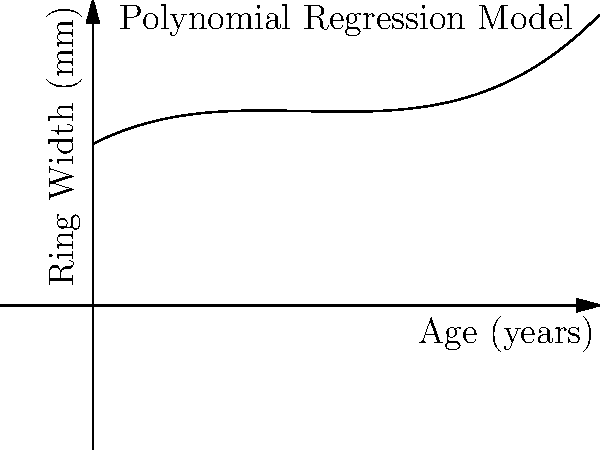As a retired carpenter with an interest in genealogy, you've come across an antique wooden chair that you believe belonged to your great-grandfather. Using your knowledge of tree rings and the polynomial regression model for estimating furniture age shown in the graph, what is the approximate age of the chair if the average ring width measured from a small, non-destructive sample is 65 mm? To estimate the age of the wooden chair using the polynomial regression model, we need to follow these steps:

1. The graph shows a polynomial function relating the age of wooden furniture to the width of tree rings.

2. The function appears to be a cubic polynomial of the form:
   $f(x) = ax^3 + bx^2 + cx + d$
   where $x$ is the age in years and $f(x)$ is the ring width in mm.

3. We need to find the $x$ value (age) that corresponds to $f(x) = 65$ mm (the measured ring width).

4. Looking at the graph, we can see that the 65 mm ring width intersects the curve at two points. Since we're dealing with an antique, we're interested in the larger age value.

5. By visual estimation, the intersection point we're interested in appears to be close to 15 years on the x-axis.

6. Given the imprecision of visual estimation and potential variations in actual measurements, it's reasonable to give an approximate age range rather than a single value.

7. A conservative estimate would be that the chair is between 14 and 16 years old.

Therefore, based on this model and the given ring width measurement, we can estimate that the antique chair is approximately 15 years old, give or take a year.
Answer: Approximately 15 years old 